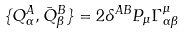<formula> <loc_0><loc_0><loc_500><loc_500>\{ Q ^ { A } _ { \alpha } , \bar { Q } ^ { B } _ { \beta } \} = 2 \delta ^ { A B } P _ { \mu } \Gamma ^ { \mu } _ { \alpha \beta }</formula> 